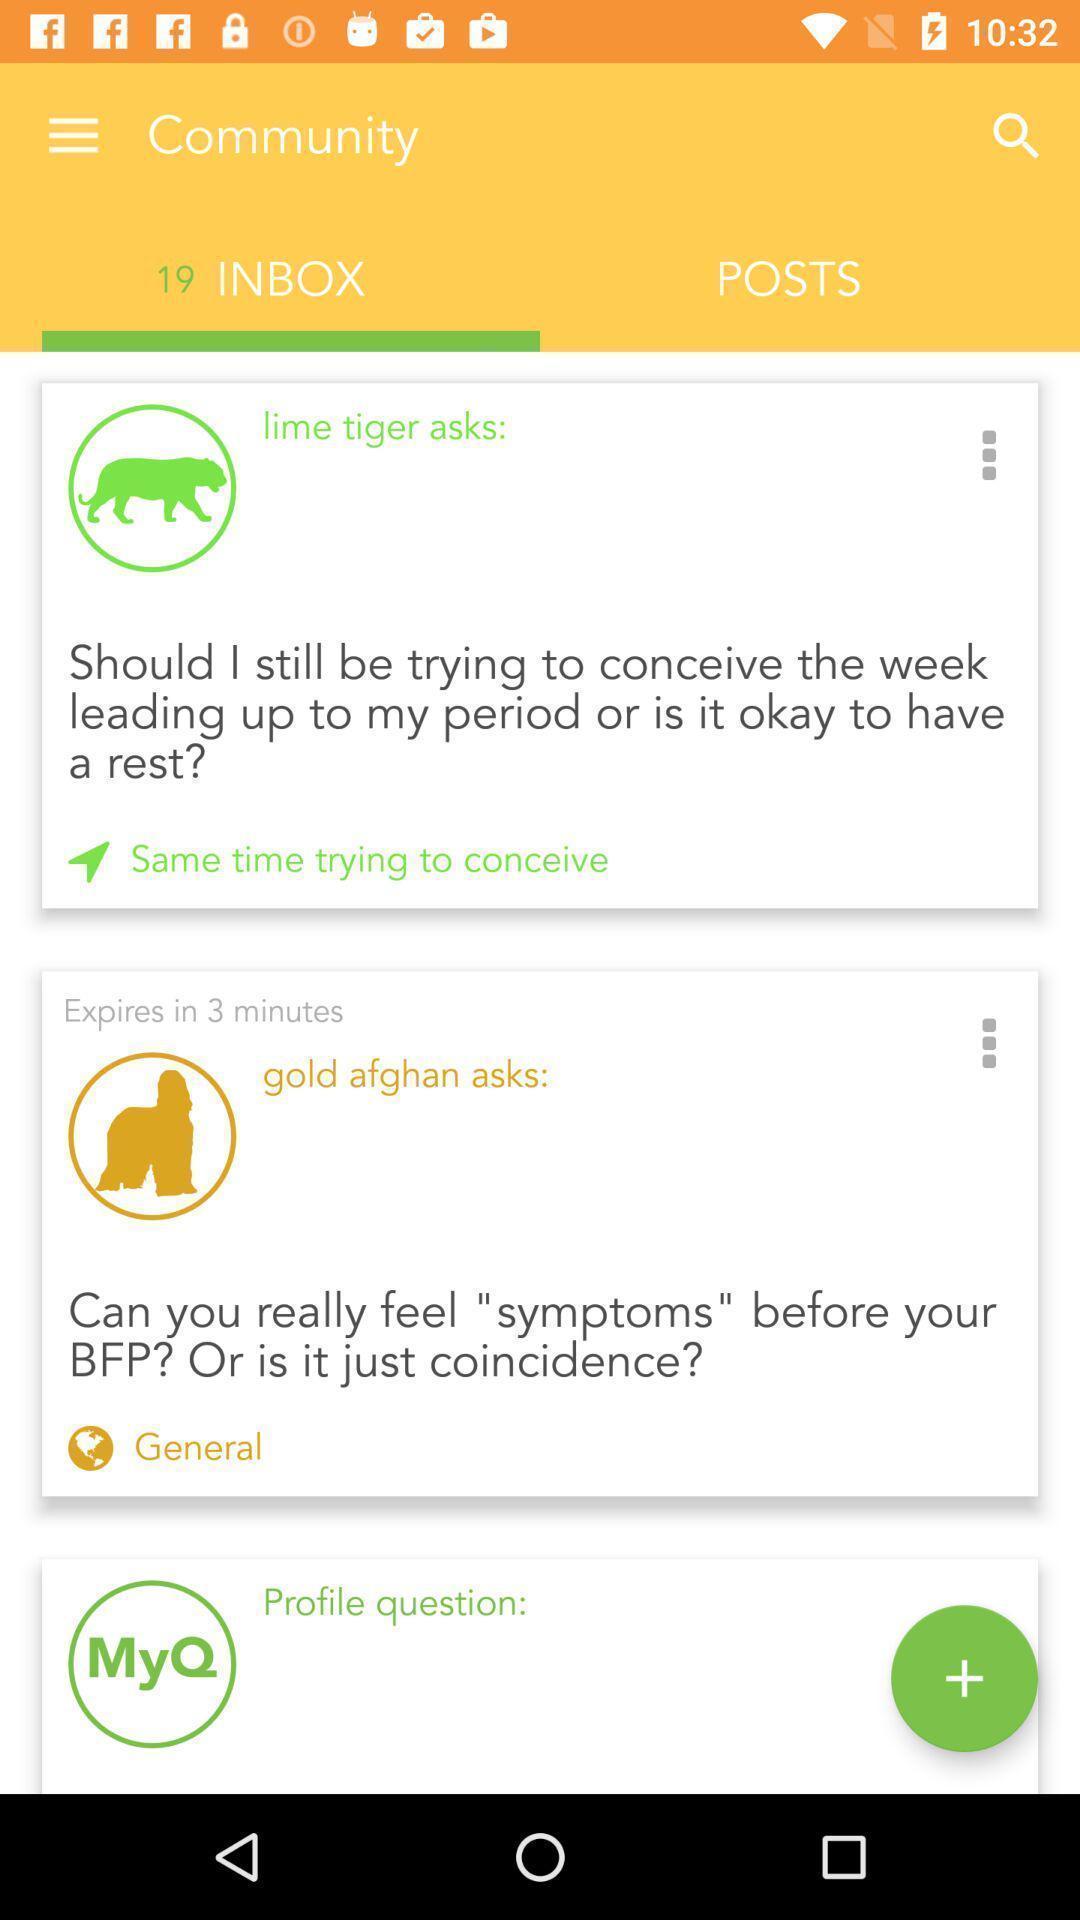Describe this image in words. Page displays list of notifications in inbox. 